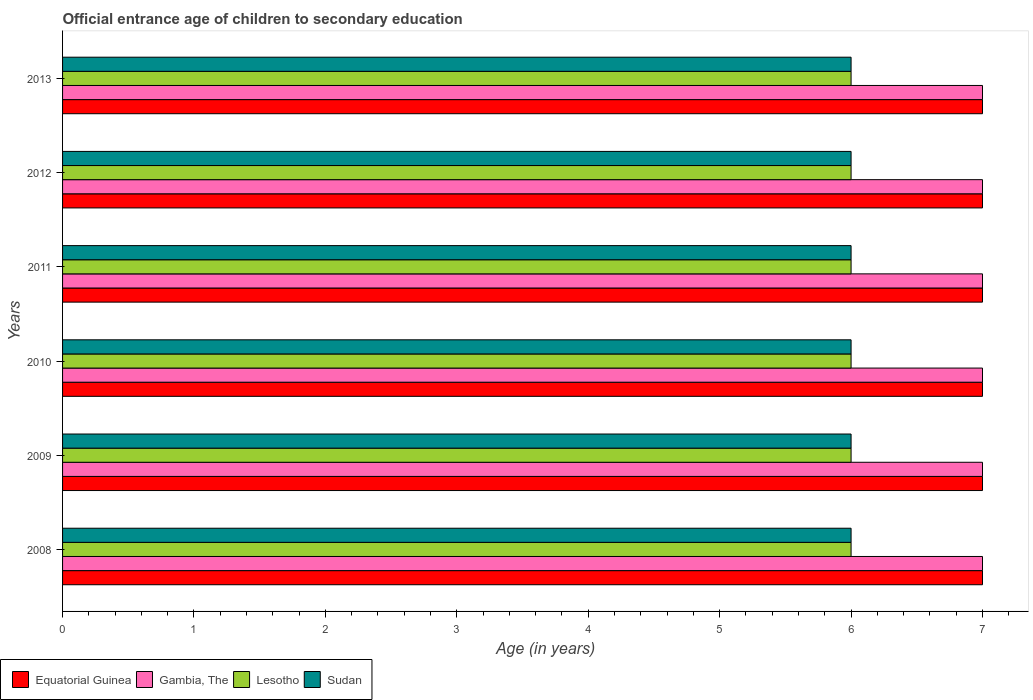How many different coloured bars are there?
Offer a very short reply. 4. How many groups of bars are there?
Give a very brief answer. 6. Are the number of bars on each tick of the Y-axis equal?
Ensure brevity in your answer.  Yes. How many bars are there on the 1st tick from the bottom?
Make the answer very short. 4. Across all years, what is the minimum secondary school starting age of children in Lesotho?
Provide a succinct answer. 6. In which year was the secondary school starting age of children in Gambia, The maximum?
Offer a terse response. 2008. What is the total secondary school starting age of children in Gambia, The in the graph?
Give a very brief answer. 42. What is the difference between the secondary school starting age of children in Lesotho in 2012 and that in 2013?
Your response must be concise. 0. In the year 2013, what is the difference between the secondary school starting age of children in Lesotho and secondary school starting age of children in Equatorial Guinea?
Provide a short and direct response. -1. In how many years, is the secondary school starting age of children in Lesotho greater than 7 years?
Give a very brief answer. 0. Is the secondary school starting age of children in Equatorial Guinea in 2010 less than that in 2012?
Your answer should be compact. No. In how many years, is the secondary school starting age of children in Lesotho greater than the average secondary school starting age of children in Lesotho taken over all years?
Provide a succinct answer. 0. Is the sum of the secondary school starting age of children in Gambia, The in 2010 and 2013 greater than the maximum secondary school starting age of children in Lesotho across all years?
Ensure brevity in your answer.  Yes. Is it the case that in every year, the sum of the secondary school starting age of children in Gambia, The and secondary school starting age of children in Equatorial Guinea is greater than the sum of secondary school starting age of children in Lesotho and secondary school starting age of children in Sudan?
Your answer should be compact. No. What does the 3rd bar from the top in 2008 represents?
Offer a very short reply. Gambia, The. What does the 2nd bar from the bottom in 2013 represents?
Your response must be concise. Gambia, The. Are the values on the major ticks of X-axis written in scientific E-notation?
Provide a short and direct response. No. Does the graph contain grids?
Keep it short and to the point. No. How many legend labels are there?
Ensure brevity in your answer.  4. What is the title of the graph?
Provide a succinct answer. Official entrance age of children to secondary education. Does "Turkey" appear as one of the legend labels in the graph?
Your response must be concise. No. What is the label or title of the X-axis?
Make the answer very short. Age (in years). What is the Age (in years) in Equatorial Guinea in 2008?
Provide a short and direct response. 7. What is the Age (in years) in Lesotho in 2008?
Your answer should be compact. 6. What is the Age (in years) of Equatorial Guinea in 2009?
Your answer should be very brief. 7. What is the Age (in years) of Lesotho in 2009?
Ensure brevity in your answer.  6. What is the Age (in years) in Equatorial Guinea in 2010?
Your answer should be compact. 7. What is the Age (in years) of Sudan in 2010?
Provide a short and direct response. 6. What is the Age (in years) in Equatorial Guinea in 2011?
Keep it short and to the point. 7. What is the Age (in years) in Equatorial Guinea in 2012?
Ensure brevity in your answer.  7. What is the Age (in years) of Sudan in 2012?
Offer a very short reply. 6. What is the Age (in years) in Equatorial Guinea in 2013?
Your answer should be very brief. 7. Across all years, what is the maximum Age (in years) of Gambia, The?
Provide a short and direct response. 7. Across all years, what is the maximum Age (in years) in Sudan?
Provide a short and direct response. 6. Across all years, what is the minimum Age (in years) of Lesotho?
Your answer should be very brief. 6. What is the total Age (in years) of Equatorial Guinea in the graph?
Ensure brevity in your answer.  42. What is the total Age (in years) of Gambia, The in the graph?
Ensure brevity in your answer.  42. What is the total Age (in years) of Lesotho in the graph?
Offer a very short reply. 36. What is the difference between the Age (in years) in Equatorial Guinea in 2008 and that in 2009?
Offer a very short reply. 0. What is the difference between the Age (in years) in Gambia, The in 2008 and that in 2009?
Provide a short and direct response. 0. What is the difference between the Age (in years) of Lesotho in 2008 and that in 2009?
Make the answer very short. 0. What is the difference between the Age (in years) of Equatorial Guinea in 2008 and that in 2010?
Offer a terse response. 0. What is the difference between the Age (in years) in Lesotho in 2008 and that in 2010?
Provide a short and direct response. 0. What is the difference between the Age (in years) of Lesotho in 2008 and that in 2011?
Provide a short and direct response. 0. What is the difference between the Age (in years) of Sudan in 2008 and that in 2011?
Offer a terse response. 0. What is the difference between the Age (in years) in Gambia, The in 2008 and that in 2012?
Your response must be concise. 0. What is the difference between the Age (in years) of Sudan in 2008 and that in 2012?
Provide a succinct answer. 0. What is the difference between the Age (in years) of Lesotho in 2008 and that in 2013?
Your response must be concise. 0. What is the difference between the Age (in years) of Gambia, The in 2009 and that in 2010?
Provide a short and direct response. 0. What is the difference between the Age (in years) of Sudan in 2009 and that in 2010?
Give a very brief answer. 0. What is the difference between the Age (in years) in Gambia, The in 2009 and that in 2011?
Give a very brief answer. 0. What is the difference between the Age (in years) of Lesotho in 2009 and that in 2011?
Keep it short and to the point. 0. What is the difference between the Age (in years) of Sudan in 2009 and that in 2011?
Ensure brevity in your answer.  0. What is the difference between the Age (in years) of Equatorial Guinea in 2009 and that in 2012?
Your answer should be compact. 0. What is the difference between the Age (in years) of Sudan in 2009 and that in 2012?
Keep it short and to the point. 0. What is the difference between the Age (in years) in Sudan in 2009 and that in 2013?
Ensure brevity in your answer.  0. What is the difference between the Age (in years) in Equatorial Guinea in 2010 and that in 2011?
Keep it short and to the point. 0. What is the difference between the Age (in years) in Sudan in 2010 and that in 2011?
Keep it short and to the point. 0. What is the difference between the Age (in years) in Lesotho in 2010 and that in 2012?
Provide a short and direct response. 0. What is the difference between the Age (in years) of Sudan in 2010 and that in 2012?
Ensure brevity in your answer.  0. What is the difference between the Age (in years) in Lesotho in 2010 and that in 2013?
Your answer should be very brief. 0. What is the difference between the Age (in years) in Sudan in 2010 and that in 2013?
Keep it short and to the point. 0. What is the difference between the Age (in years) in Equatorial Guinea in 2011 and that in 2012?
Your answer should be very brief. 0. What is the difference between the Age (in years) in Lesotho in 2011 and that in 2012?
Your answer should be compact. 0. What is the difference between the Age (in years) in Sudan in 2011 and that in 2012?
Provide a succinct answer. 0. What is the difference between the Age (in years) in Gambia, The in 2011 and that in 2013?
Your response must be concise. 0. What is the difference between the Age (in years) in Lesotho in 2011 and that in 2013?
Offer a terse response. 0. What is the difference between the Age (in years) in Equatorial Guinea in 2012 and that in 2013?
Give a very brief answer. 0. What is the difference between the Age (in years) in Equatorial Guinea in 2008 and the Age (in years) in Sudan in 2009?
Ensure brevity in your answer.  1. What is the difference between the Age (in years) in Lesotho in 2008 and the Age (in years) in Sudan in 2009?
Your response must be concise. 0. What is the difference between the Age (in years) of Equatorial Guinea in 2008 and the Age (in years) of Gambia, The in 2010?
Make the answer very short. 0. What is the difference between the Age (in years) of Gambia, The in 2008 and the Age (in years) of Lesotho in 2010?
Give a very brief answer. 1. What is the difference between the Age (in years) in Gambia, The in 2008 and the Age (in years) in Sudan in 2010?
Offer a terse response. 1. What is the difference between the Age (in years) in Lesotho in 2008 and the Age (in years) in Sudan in 2010?
Your answer should be very brief. 0. What is the difference between the Age (in years) of Equatorial Guinea in 2008 and the Age (in years) of Gambia, The in 2011?
Make the answer very short. 0. What is the difference between the Age (in years) in Equatorial Guinea in 2008 and the Age (in years) in Sudan in 2011?
Provide a short and direct response. 1. What is the difference between the Age (in years) in Lesotho in 2008 and the Age (in years) in Sudan in 2011?
Your answer should be very brief. 0. What is the difference between the Age (in years) in Equatorial Guinea in 2008 and the Age (in years) in Gambia, The in 2012?
Offer a very short reply. 0. What is the difference between the Age (in years) in Gambia, The in 2008 and the Age (in years) in Lesotho in 2012?
Keep it short and to the point. 1. What is the difference between the Age (in years) of Gambia, The in 2008 and the Age (in years) of Sudan in 2012?
Provide a short and direct response. 1. What is the difference between the Age (in years) of Lesotho in 2008 and the Age (in years) of Sudan in 2012?
Ensure brevity in your answer.  0. What is the difference between the Age (in years) in Equatorial Guinea in 2008 and the Age (in years) in Lesotho in 2013?
Your response must be concise. 1. What is the difference between the Age (in years) of Gambia, The in 2008 and the Age (in years) of Sudan in 2013?
Your response must be concise. 1. What is the difference between the Age (in years) in Lesotho in 2008 and the Age (in years) in Sudan in 2013?
Offer a terse response. 0. What is the difference between the Age (in years) of Equatorial Guinea in 2009 and the Age (in years) of Sudan in 2010?
Keep it short and to the point. 1. What is the difference between the Age (in years) of Gambia, The in 2009 and the Age (in years) of Lesotho in 2010?
Your answer should be very brief. 1. What is the difference between the Age (in years) of Gambia, The in 2009 and the Age (in years) of Sudan in 2010?
Provide a succinct answer. 1. What is the difference between the Age (in years) of Lesotho in 2009 and the Age (in years) of Sudan in 2010?
Provide a short and direct response. 0. What is the difference between the Age (in years) in Equatorial Guinea in 2009 and the Age (in years) in Gambia, The in 2011?
Your response must be concise. 0. What is the difference between the Age (in years) in Equatorial Guinea in 2009 and the Age (in years) in Lesotho in 2011?
Offer a terse response. 1. What is the difference between the Age (in years) of Lesotho in 2009 and the Age (in years) of Sudan in 2011?
Your response must be concise. 0. What is the difference between the Age (in years) of Equatorial Guinea in 2009 and the Age (in years) of Gambia, The in 2012?
Ensure brevity in your answer.  0. What is the difference between the Age (in years) of Equatorial Guinea in 2009 and the Age (in years) of Lesotho in 2012?
Offer a terse response. 1. What is the difference between the Age (in years) of Gambia, The in 2009 and the Age (in years) of Sudan in 2012?
Provide a succinct answer. 1. What is the difference between the Age (in years) of Lesotho in 2009 and the Age (in years) of Sudan in 2012?
Your answer should be very brief. 0. What is the difference between the Age (in years) in Equatorial Guinea in 2009 and the Age (in years) in Lesotho in 2013?
Your response must be concise. 1. What is the difference between the Age (in years) in Equatorial Guinea in 2009 and the Age (in years) in Sudan in 2013?
Offer a terse response. 1. What is the difference between the Age (in years) of Gambia, The in 2009 and the Age (in years) of Lesotho in 2013?
Keep it short and to the point. 1. What is the difference between the Age (in years) in Lesotho in 2009 and the Age (in years) in Sudan in 2013?
Make the answer very short. 0. What is the difference between the Age (in years) of Equatorial Guinea in 2010 and the Age (in years) of Gambia, The in 2011?
Provide a succinct answer. 0. What is the difference between the Age (in years) in Equatorial Guinea in 2010 and the Age (in years) in Sudan in 2011?
Keep it short and to the point. 1. What is the difference between the Age (in years) in Gambia, The in 2010 and the Age (in years) in Lesotho in 2011?
Provide a short and direct response. 1. What is the difference between the Age (in years) of Equatorial Guinea in 2010 and the Age (in years) of Lesotho in 2012?
Make the answer very short. 1. What is the difference between the Age (in years) in Equatorial Guinea in 2010 and the Age (in years) in Sudan in 2012?
Your response must be concise. 1. What is the difference between the Age (in years) of Gambia, The in 2010 and the Age (in years) of Sudan in 2012?
Make the answer very short. 1. What is the difference between the Age (in years) in Lesotho in 2010 and the Age (in years) in Sudan in 2012?
Give a very brief answer. 0. What is the difference between the Age (in years) of Equatorial Guinea in 2010 and the Age (in years) of Sudan in 2013?
Offer a very short reply. 1. What is the difference between the Age (in years) in Lesotho in 2010 and the Age (in years) in Sudan in 2013?
Provide a succinct answer. 0. What is the difference between the Age (in years) of Equatorial Guinea in 2011 and the Age (in years) of Lesotho in 2012?
Your answer should be very brief. 1. What is the difference between the Age (in years) of Equatorial Guinea in 2011 and the Age (in years) of Sudan in 2012?
Make the answer very short. 1. What is the difference between the Age (in years) in Gambia, The in 2011 and the Age (in years) in Sudan in 2012?
Offer a very short reply. 1. What is the difference between the Age (in years) in Lesotho in 2011 and the Age (in years) in Sudan in 2012?
Your response must be concise. 0. What is the difference between the Age (in years) of Equatorial Guinea in 2011 and the Age (in years) of Lesotho in 2013?
Offer a very short reply. 1. What is the difference between the Age (in years) in Gambia, The in 2011 and the Age (in years) in Sudan in 2013?
Provide a succinct answer. 1. What is the difference between the Age (in years) in Lesotho in 2012 and the Age (in years) in Sudan in 2013?
Offer a terse response. 0. What is the average Age (in years) of Equatorial Guinea per year?
Ensure brevity in your answer.  7. What is the average Age (in years) of Gambia, The per year?
Provide a short and direct response. 7. What is the average Age (in years) in Sudan per year?
Your answer should be compact. 6. In the year 2008, what is the difference between the Age (in years) of Equatorial Guinea and Age (in years) of Gambia, The?
Offer a very short reply. 0. In the year 2008, what is the difference between the Age (in years) in Equatorial Guinea and Age (in years) in Sudan?
Make the answer very short. 1. In the year 2009, what is the difference between the Age (in years) of Equatorial Guinea and Age (in years) of Gambia, The?
Provide a short and direct response. 0. In the year 2009, what is the difference between the Age (in years) of Equatorial Guinea and Age (in years) of Lesotho?
Offer a terse response. 1. In the year 2009, what is the difference between the Age (in years) of Gambia, The and Age (in years) of Lesotho?
Offer a terse response. 1. In the year 2009, what is the difference between the Age (in years) in Gambia, The and Age (in years) in Sudan?
Offer a very short reply. 1. In the year 2009, what is the difference between the Age (in years) in Lesotho and Age (in years) in Sudan?
Your response must be concise. 0. In the year 2010, what is the difference between the Age (in years) of Equatorial Guinea and Age (in years) of Sudan?
Ensure brevity in your answer.  1. In the year 2010, what is the difference between the Age (in years) of Gambia, The and Age (in years) of Sudan?
Ensure brevity in your answer.  1. In the year 2011, what is the difference between the Age (in years) of Equatorial Guinea and Age (in years) of Gambia, The?
Give a very brief answer. 0. In the year 2011, what is the difference between the Age (in years) in Gambia, The and Age (in years) in Lesotho?
Your answer should be compact. 1. In the year 2011, what is the difference between the Age (in years) of Lesotho and Age (in years) of Sudan?
Keep it short and to the point. 0. In the year 2012, what is the difference between the Age (in years) in Equatorial Guinea and Age (in years) in Gambia, The?
Your answer should be very brief. 0. In the year 2012, what is the difference between the Age (in years) of Equatorial Guinea and Age (in years) of Sudan?
Your answer should be compact. 1. In the year 2012, what is the difference between the Age (in years) in Gambia, The and Age (in years) in Lesotho?
Your response must be concise. 1. In the year 2012, what is the difference between the Age (in years) of Gambia, The and Age (in years) of Sudan?
Make the answer very short. 1. In the year 2012, what is the difference between the Age (in years) in Lesotho and Age (in years) in Sudan?
Give a very brief answer. 0. In the year 2013, what is the difference between the Age (in years) of Equatorial Guinea and Age (in years) of Sudan?
Provide a short and direct response. 1. In the year 2013, what is the difference between the Age (in years) of Gambia, The and Age (in years) of Sudan?
Offer a terse response. 1. In the year 2013, what is the difference between the Age (in years) of Lesotho and Age (in years) of Sudan?
Your answer should be compact. 0. What is the ratio of the Age (in years) of Lesotho in 2008 to that in 2009?
Keep it short and to the point. 1. What is the ratio of the Age (in years) in Sudan in 2008 to that in 2009?
Your answer should be compact. 1. What is the ratio of the Age (in years) of Equatorial Guinea in 2008 to that in 2010?
Keep it short and to the point. 1. What is the ratio of the Age (in years) of Sudan in 2008 to that in 2010?
Ensure brevity in your answer.  1. What is the ratio of the Age (in years) in Equatorial Guinea in 2008 to that in 2011?
Keep it short and to the point. 1. What is the ratio of the Age (in years) in Sudan in 2008 to that in 2011?
Offer a terse response. 1. What is the ratio of the Age (in years) of Equatorial Guinea in 2008 to that in 2012?
Your answer should be compact. 1. What is the ratio of the Age (in years) of Gambia, The in 2008 to that in 2012?
Provide a succinct answer. 1. What is the ratio of the Age (in years) in Sudan in 2008 to that in 2012?
Your answer should be very brief. 1. What is the ratio of the Age (in years) of Equatorial Guinea in 2008 to that in 2013?
Make the answer very short. 1. What is the ratio of the Age (in years) in Sudan in 2008 to that in 2013?
Make the answer very short. 1. What is the ratio of the Age (in years) in Equatorial Guinea in 2009 to that in 2010?
Give a very brief answer. 1. What is the ratio of the Age (in years) in Gambia, The in 2009 to that in 2010?
Give a very brief answer. 1. What is the ratio of the Age (in years) in Equatorial Guinea in 2009 to that in 2011?
Offer a very short reply. 1. What is the ratio of the Age (in years) in Sudan in 2009 to that in 2011?
Offer a very short reply. 1. What is the ratio of the Age (in years) of Lesotho in 2009 to that in 2012?
Make the answer very short. 1. What is the ratio of the Age (in years) in Sudan in 2009 to that in 2012?
Ensure brevity in your answer.  1. What is the ratio of the Age (in years) in Gambia, The in 2009 to that in 2013?
Make the answer very short. 1. What is the ratio of the Age (in years) in Lesotho in 2009 to that in 2013?
Keep it short and to the point. 1. What is the ratio of the Age (in years) of Sudan in 2010 to that in 2011?
Provide a short and direct response. 1. What is the ratio of the Age (in years) of Equatorial Guinea in 2010 to that in 2012?
Offer a very short reply. 1. What is the ratio of the Age (in years) of Lesotho in 2010 to that in 2012?
Your answer should be compact. 1. What is the ratio of the Age (in years) in Sudan in 2010 to that in 2012?
Give a very brief answer. 1. What is the ratio of the Age (in years) in Equatorial Guinea in 2010 to that in 2013?
Provide a short and direct response. 1. What is the ratio of the Age (in years) in Equatorial Guinea in 2011 to that in 2012?
Your response must be concise. 1. What is the ratio of the Age (in years) of Gambia, The in 2011 to that in 2012?
Your answer should be very brief. 1. What is the ratio of the Age (in years) in Lesotho in 2011 to that in 2012?
Offer a terse response. 1. What is the ratio of the Age (in years) of Equatorial Guinea in 2011 to that in 2013?
Ensure brevity in your answer.  1. What is the ratio of the Age (in years) of Gambia, The in 2011 to that in 2013?
Your response must be concise. 1. What is the difference between the highest and the second highest Age (in years) in Equatorial Guinea?
Offer a very short reply. 0. What is the difference between the highest and the lowest Age (in years) of Equatorial Guinea?
Your answer should be very brief. 0. What is the difference between the highest and the lowest Age (in years) in Lesotho?
Your answer should be compact. 0. What is the difference between the highest and the lowest Age (in years) in Sudan?
Ensure brevity in your answer.  0. 